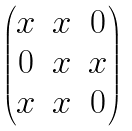<formula> <loc_0><loc_0><loc_500><loc_500>\begin{pmatrix} x & x & 0 \\ 0 & x & x \\ x & x & 0 \\ \end{pmatrix}</formula> 